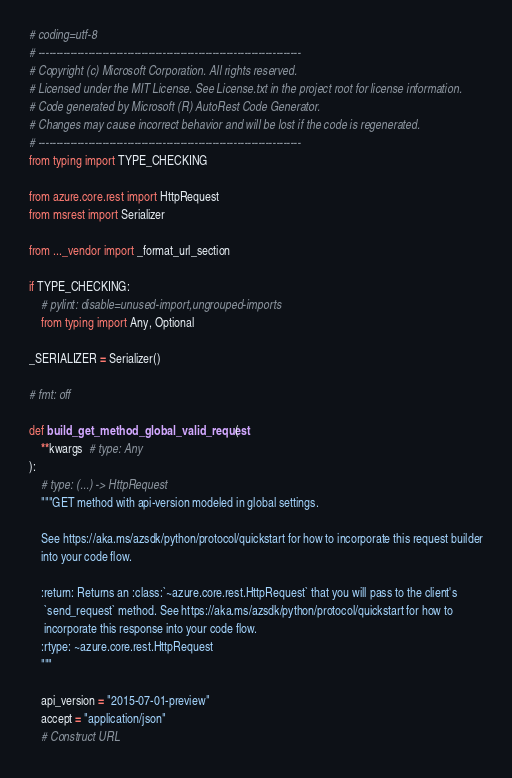Convert code to text. <code><loc_0><loc_0><loc_500><loc_500><_Python_># coding=utf-8
# --------------------------------------------------------------------------
# Copyright (c) Microsoft Corporation. All rights reserved.
# Licensed under the MIT License. See License.txt in the project root for license information.
# Code generated by Microsoft (R) AutoRest Code Generator.
# Changes may cause incorrect behavior and will be lost if the code is regenerated.
# --------------------------------------------------------------------------
from typing import TYPE_CHECKING

from azure.core.rest import HttpRequest
from msrest import Serializer

from ..._vendor import _format_url_section

if TYPE_CHECKING:
    # pylint: disable=unused-import,ungrouped-imports
    from typing import Any, Optional

_SERIALIZER = Serializer()

# fmt: off

def build_get_method_global_valid_request(
    **kwargs  # type: Any
):
    # type: (...) -> HttpRequest
    """GET method with api-version modeled in global settings.

    See https://aka.ms/azsdk/python/protocol/quickstart for how to incorporate this request builder
    into your code flow.

    :return: Returns an :class:`~azure.core.rest.HttpRequest` that you will pass to the client's
     `send_request` method. See https://aka.ms/azsdk/python/protocol/quickstart for how to
     incorporate this response into your code flow.
    :rtype: ~azure.core.rest.HttpRequest
    """

    api_version = "2015-07-01-preview"
    accept = "application/json"
    # Construct URL</code> 